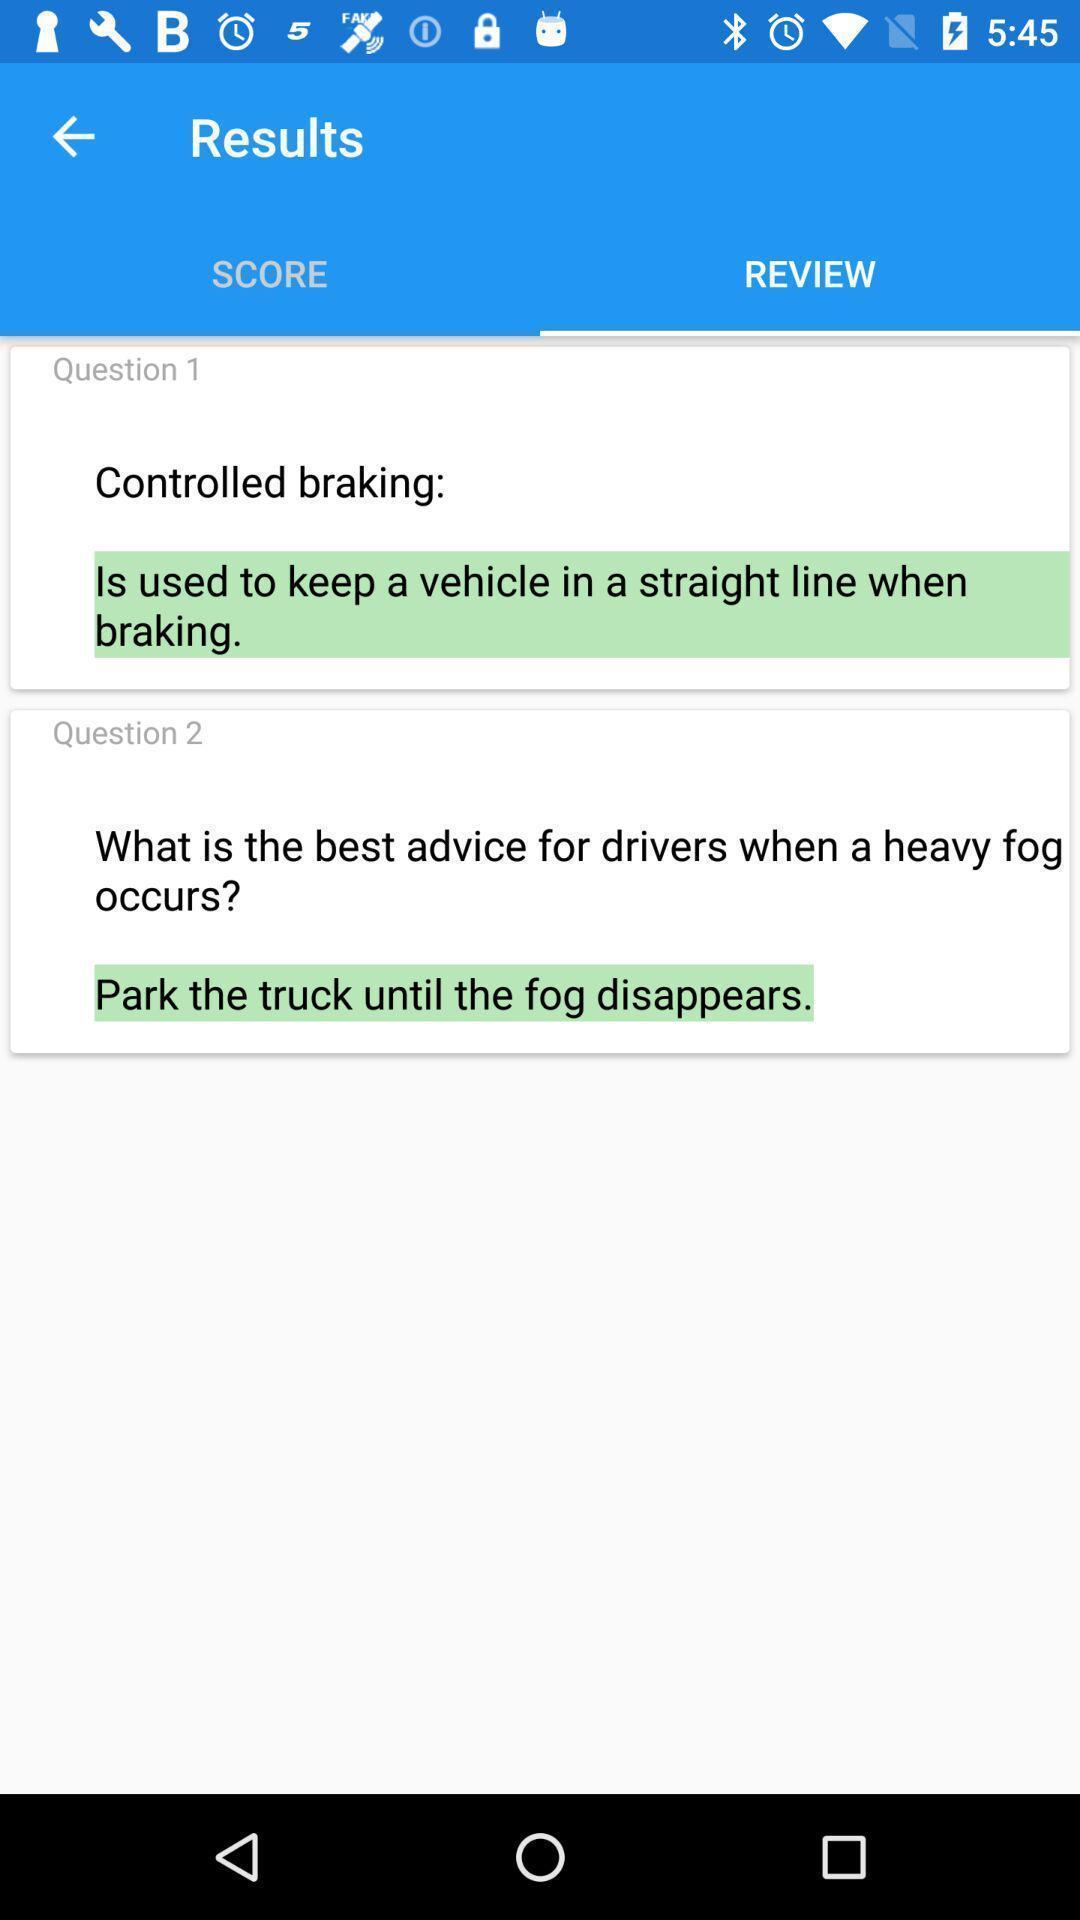Provide a description of this screenshot. Reviews tab with different kinds of questions in the application. 